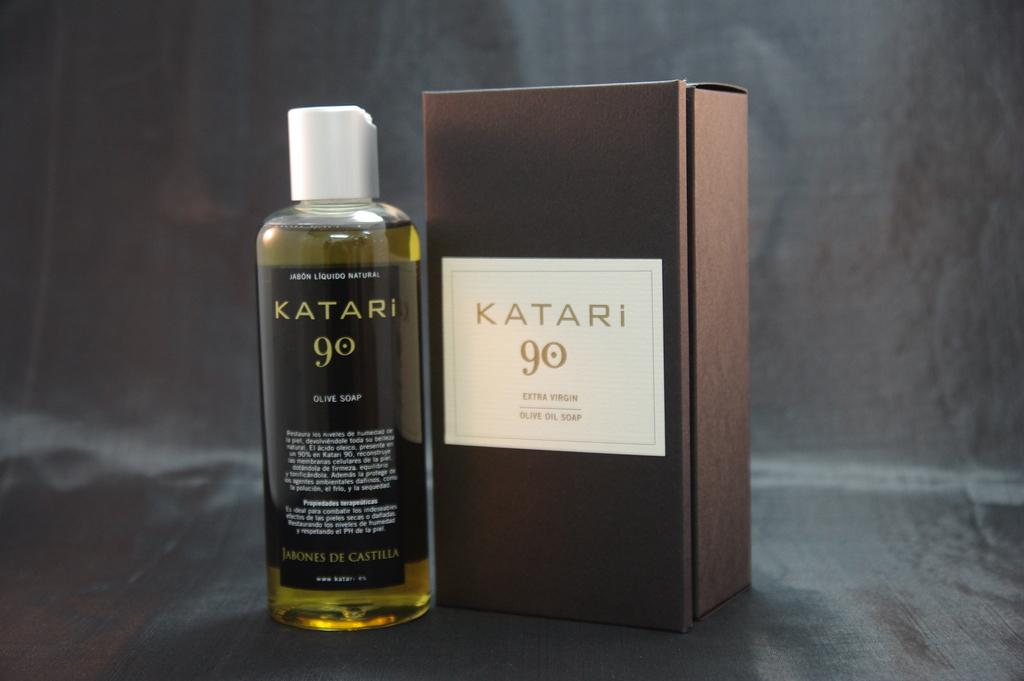What object can be seen in the image that might contain items? There is a box in the image that might contain items. What type of container is visible in the image that holds a liquid? There is a liquid bottle in the image that holds a liquid. What color is the cap of the liquid bottle? The liquid bottle has a white cap. Can you see a squirrel interacting with the box in the image? There is no squirrel present in the image. What type of cough medicine is in the liquid bottle? The image does not provide information about the contents of the liquid bottle, so it cannot be determined if it contains cough medicine. 